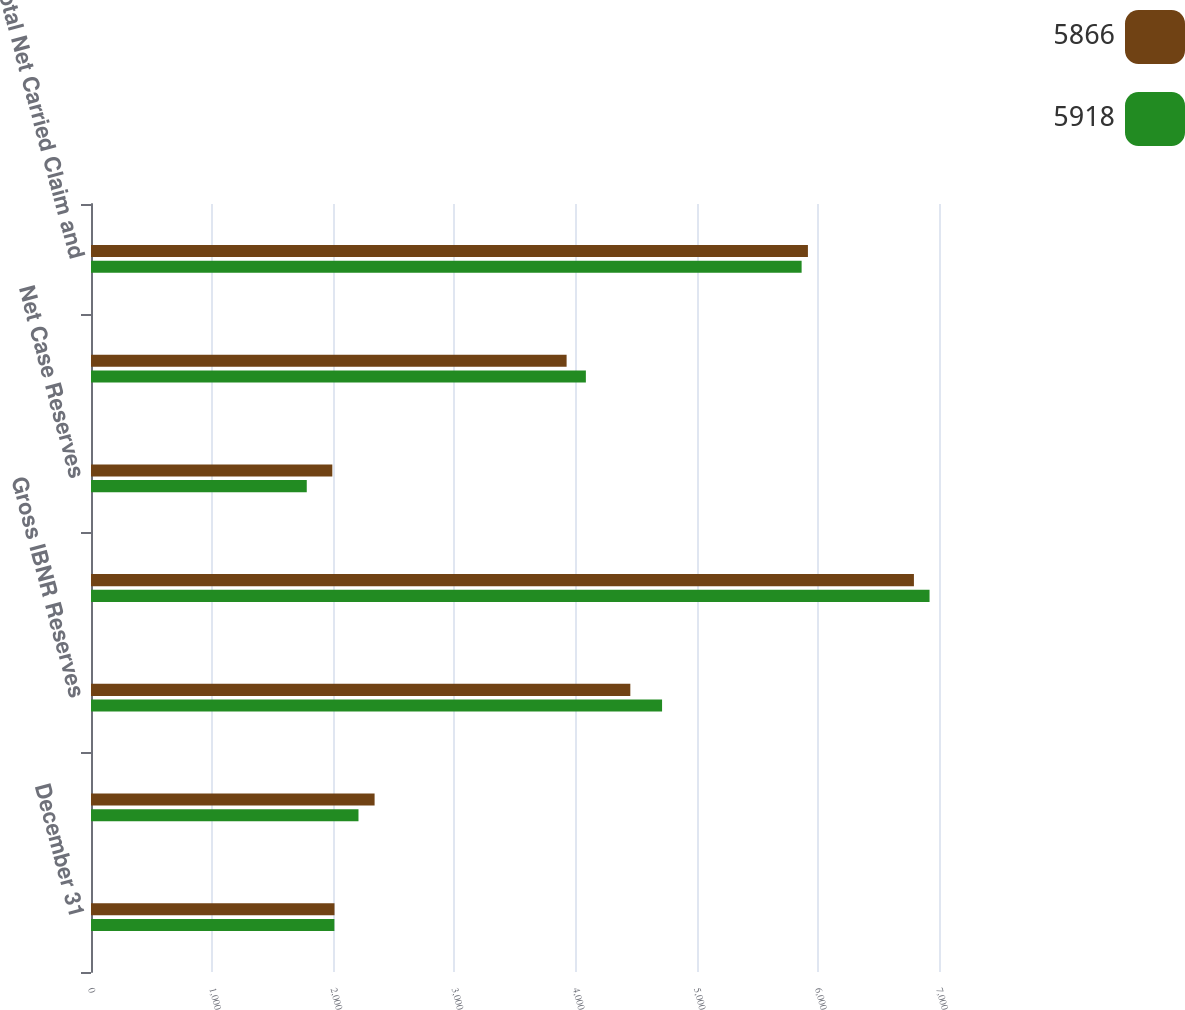Convert chart to OTSL. <chart><loc_0><loc_0><loc_500><loc_500><stacked_bar_chart><ecel><fcel>December 31<fcel>Gross Case Reserves<fcel>Gross IBNR Reserves<fcel>Total Gross Carried Claim and<fcel>Net Case Reserves<fcel>Net IBNR Reserves<fcel>Total Net Carried Claim and<nl><fcel>5866<fcel>2010<fcel>2341<fcel>4452<fcel>6793<fcel>1992<fcel>3926<fcel>5918<nl><fcel>5918<fcel>2009<fcel>2208<fcel>4714<fcel>6922<fcel>1781<fcel>4085<fcel>5866<nl></chart> 